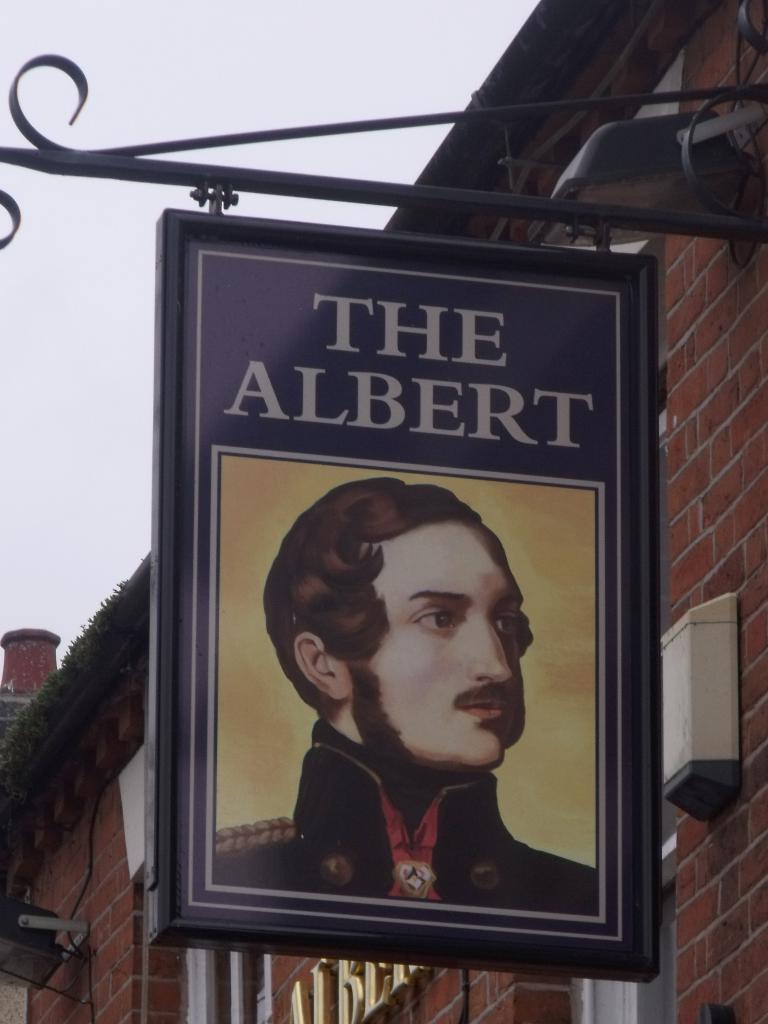Describe this image in one or two sentences. In this picture there is a poster in the center of the image, on which it is written as ''the albert.'' 